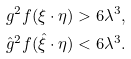Convert formula to latex. <formula><loc_0><loc_0><loc_500><loc_500>g ^ { 2 } f ( \xi \cdot \eta ) > 6 \lambda ^ { 3 } , \\ \hat { g } ^ { 2 } f ( \hat { \xi } \cdot \eta ) < 6 \lambda ^ { 3 } .</formula> 